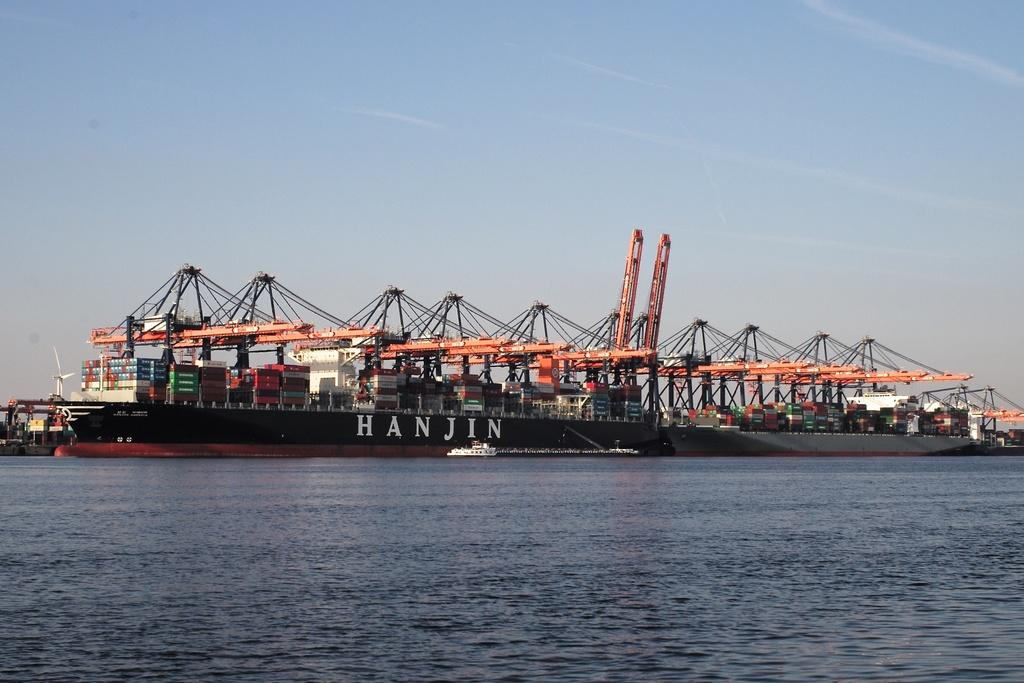<image>
Relay a brief, clear account of the picture shown. A large ship with shipping containers on it says Hanjin on the side. 